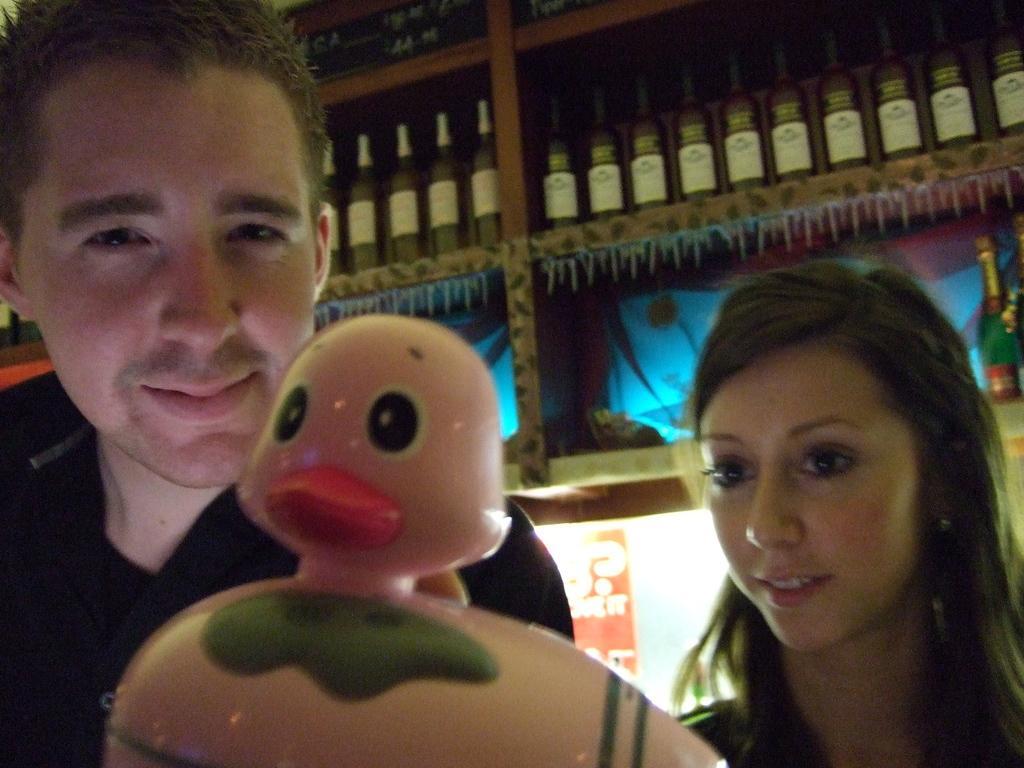In one or two sentences, can you explain what this image depicts? In this image I can see a woman and man , in front of them I can see a toy at the top I can see a rack , in the rack I can see bottles. 